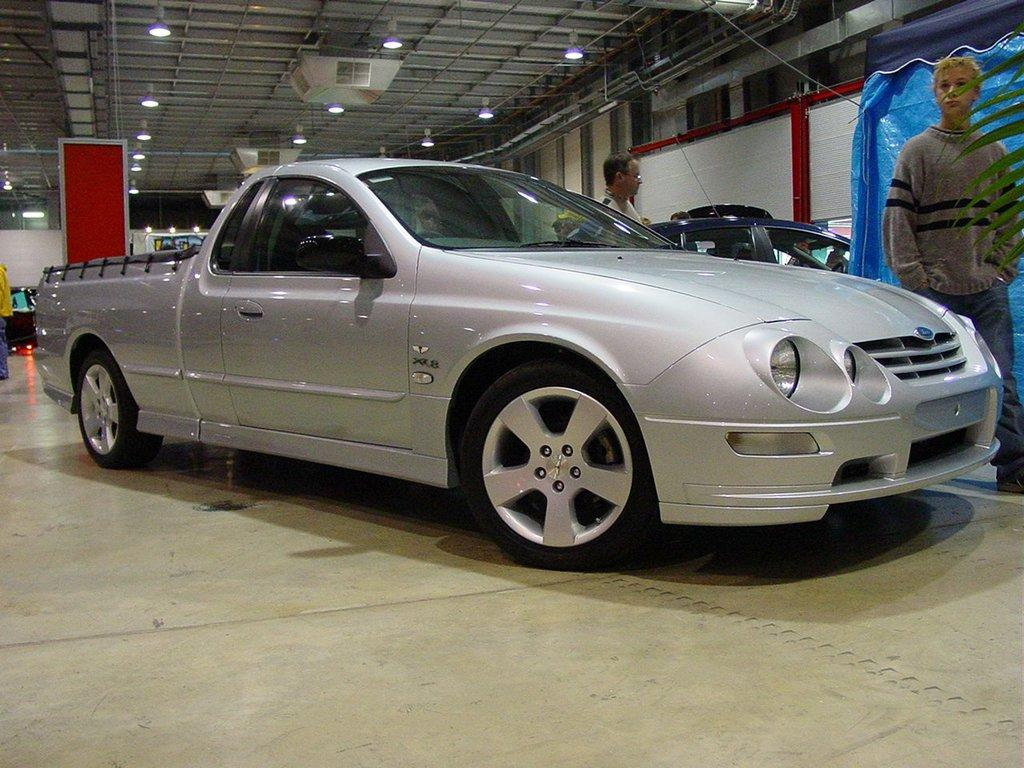What is the main subject of the image? The main subject of the image is a car. Can you describe the color of the car? The car is ash colored. What else can be seen in the image besides the car? There are two persons standing in the middle of the image. What feature of the car is visible at the top? There are lights at the top of the car. How many sheep can be seen grazing on the hill in the image? There are no sheep or hills present in the image; it features a car and two persons standing nearby. 